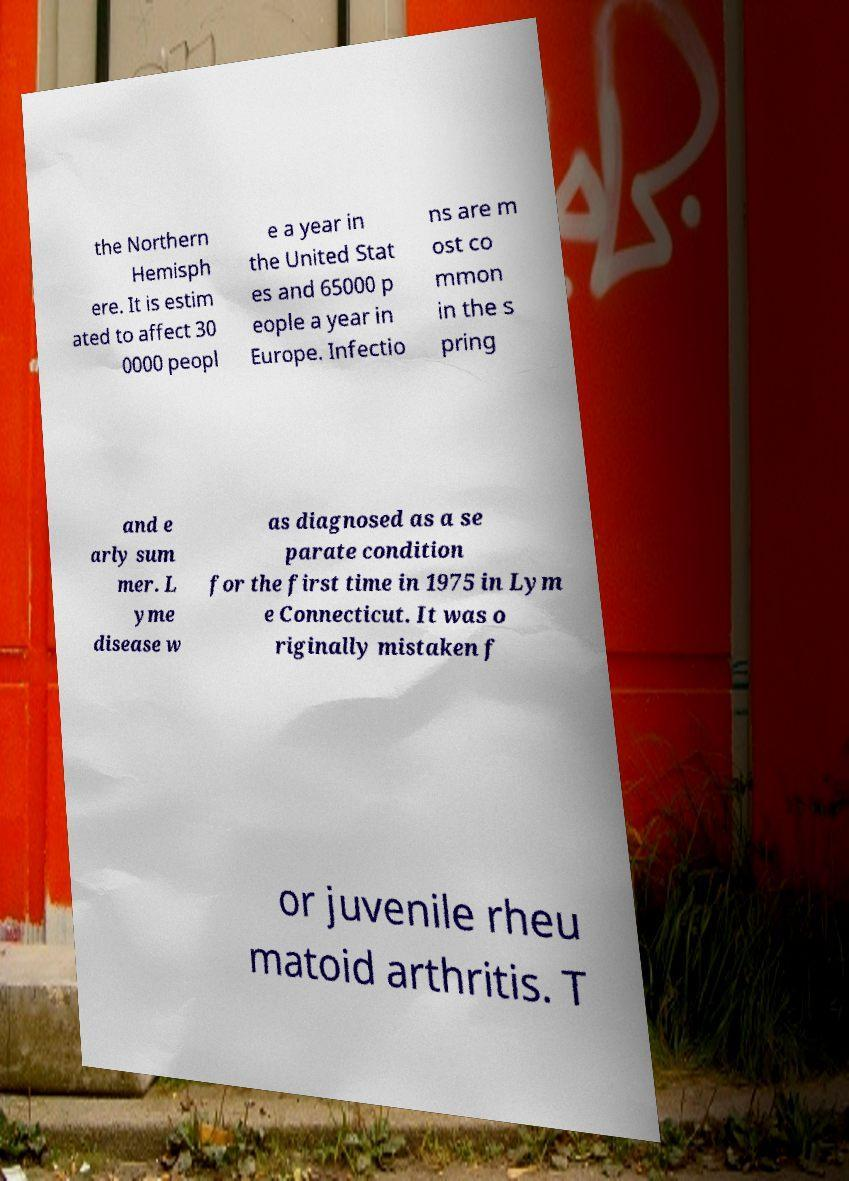Can you accurately transcribe the text from the provided image for me? the Northern Hemisph ere. It is estim ated to affect 30 0000 peopl e a year in the United Stat es and 65000 p eople a year in Europe. Infectio ns are m ost co mmon in the s pring and e arly sum mer. L yme disease w as diagnosed as a se parate condition for the first time in 1975 in Lym e Connecticut. It was o riginally mistaken f or juvenile rheu matoid arthritis. T 